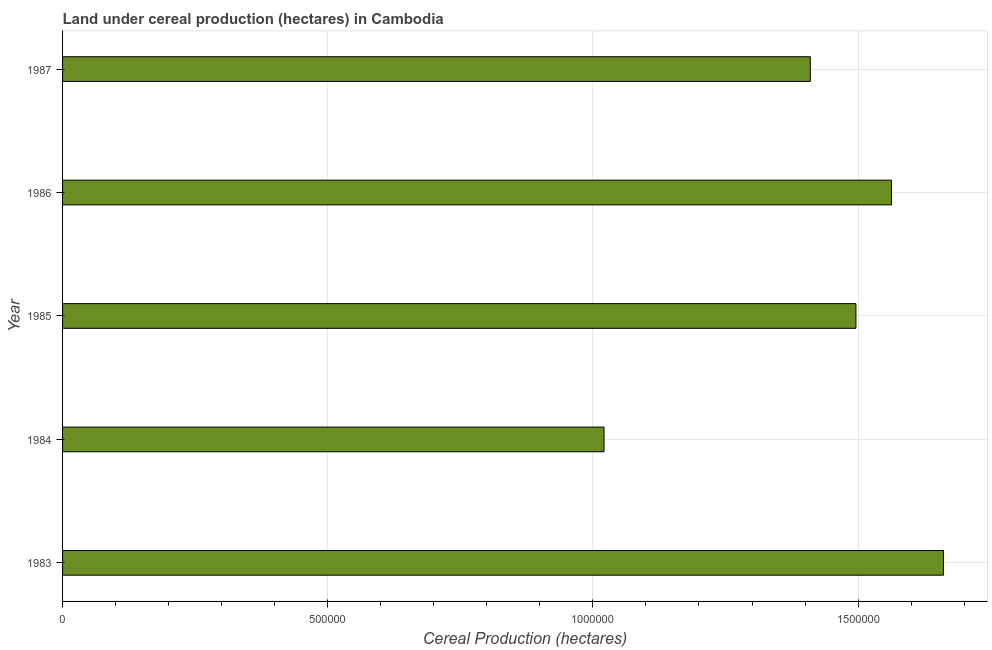Does the graph contain any zero values?
Provide a succinct answer. No. Does the graph contain grids?
Your answer should be compact. Yes. What is the title of the graph?
Your answer should be very brief. Land under cereal production (hectares) in Cambodia. What is the label or title of the X-axis?
Your answer should be compact. Cereal Production (hectares). What is the label or title of the Y-axis?
Provide a succinct answer. Year. What is the land under cereal production in 1984?
Your answer should be very brief. 1.02e+06. Across all years, what is the maximum land under cereal production?
Your answer should be very brief. 1.66e+06. Across all years, what is the minimum land under cereal production?
Provide a succinct answer. 1.02e+06. What is the sum of the land under cereal production?
Give a very brief answer. 7.15e+06. What is the difference between the land under cereal production in 1984 and 1987?
Give a very brief answer. -3.89e+05. What is the average land under cereal production per year?
Your answer should be compact. 1.43e+06. What is the median land under cereal production?
Your answer should be very brief. 1.50e+06. What is the ratio of the land under cereal production in 1985 to that in 1987?
Keep it short and to the point. 1.06. Is the difference between the land under cereal production in 1985 and 1986 greater than the difference between any two years?
Ensure brevity in your answer.  No. What is the difference between the highest and the second highest land under cereal production?
Your response must be concise. 9.80e+04. Is the sum of the land under cereal production in 1984 and 1985 greater than the maximum land under cereal production across all years?
Make the answer very short. Yes. What is the difference between the highest and the lowest land under cereal production?
Make the answer very short. 6.40e+05. In how many years, is the land under cereal production greater than the average land under cereal production taken over all years?
Make the answer very short. 3. How many bars are there?
Your response must be concise. 5. What is the Cereal Production (hectares) in 1983?
Make the answer very short. 1.66e+06. What is the Cereal Production (hectares) of 1984?
Provide a succinct answer. 1.02e+06. What is the Cereal Production (hectares) of 1985?
Make the answer very short. 1.50e+06. What is the Cereal Production (hectares) in 1986?
Your answer should be very brief. 1.56e+06. What is the Cereal Production (hectares) in 1987?
Make the answer very short. 1.41e+06. What is the difference between the Cereal Production (hectares) in 1983 and 1984?
Your answer should be very brief. 6.40e+05. What is the difference between the Cereal Production (hectares) in 1983 and 1985?
Provide a short and direct response. 1.65e+05. What is the difference between the Cereal Production (hectares) in 1983 and 1986?
Give a very brief answer. 9.80e+04. What is the difference between the Cereal Production (hectares) in 1983 and 1987?
Your response must be concise. 2.51e+05. What is the difference between the Cereal Production (hectares) in 1984 and 1985?
Offer a very short reply. -4.75e+05. What is the difference between the Cereal Production (hectares) in 1984 and 1986?
Ensure brevity in your answer.  -5.42e+05. What is the difference between the Cereal Production (hectares) in 1984 and 1987?
Your answer should be very brief. -3.89e+05. What is the difference between the Cereal Production (hectares) in 1985 and 1986?
Give a very brief answer. -6.70e+04. What is the difference between the Cereal Production (hectares) in 1985 and 1987?
Provide a short and direct response. 8.60e+04. What is the difference between the Cereal Production (hectares) in 1986 and 1987?
Give a very brief answer. 1.53e+05. What is the ratio of the Cereal Production (hectares) in 1983 to that in 1984?
Offer a very short reply. 1.63. What is the ratio of the Cereal Production (hectares) in 1983 to that in 1985?
Make the answer very short. 1.11. What is the ratio of the Cereal Production (hectares) in 1983 to that in 1986?
Provide a short and direct response. 1.06. What is the ratio of the Cereal Production (hectares) in 1983 to that in 1987?
Make the answer very short. 1.18. What is the ratio of the Cereal Production (hectares) in 1984 to that in 1985?
Provide a succinct answer. 0.68. What is the ratio of the Cereal Production (hectares) in 1984 to that in 1986?
Your answer should be very brief. 0.65. What is the ratio of the Cereal Production (hectares) in 1984 to that in 1987?
Offer a very short reply. 0.72. What is the ratio of the Cereal Production (hectares) in 1985 to that in 1987?
Keep it short and to the point. 1.06. What is the ratio of the Cereal Production (hectares) in 1986 to that in 1987?
Your response must be concise. 1.11. 